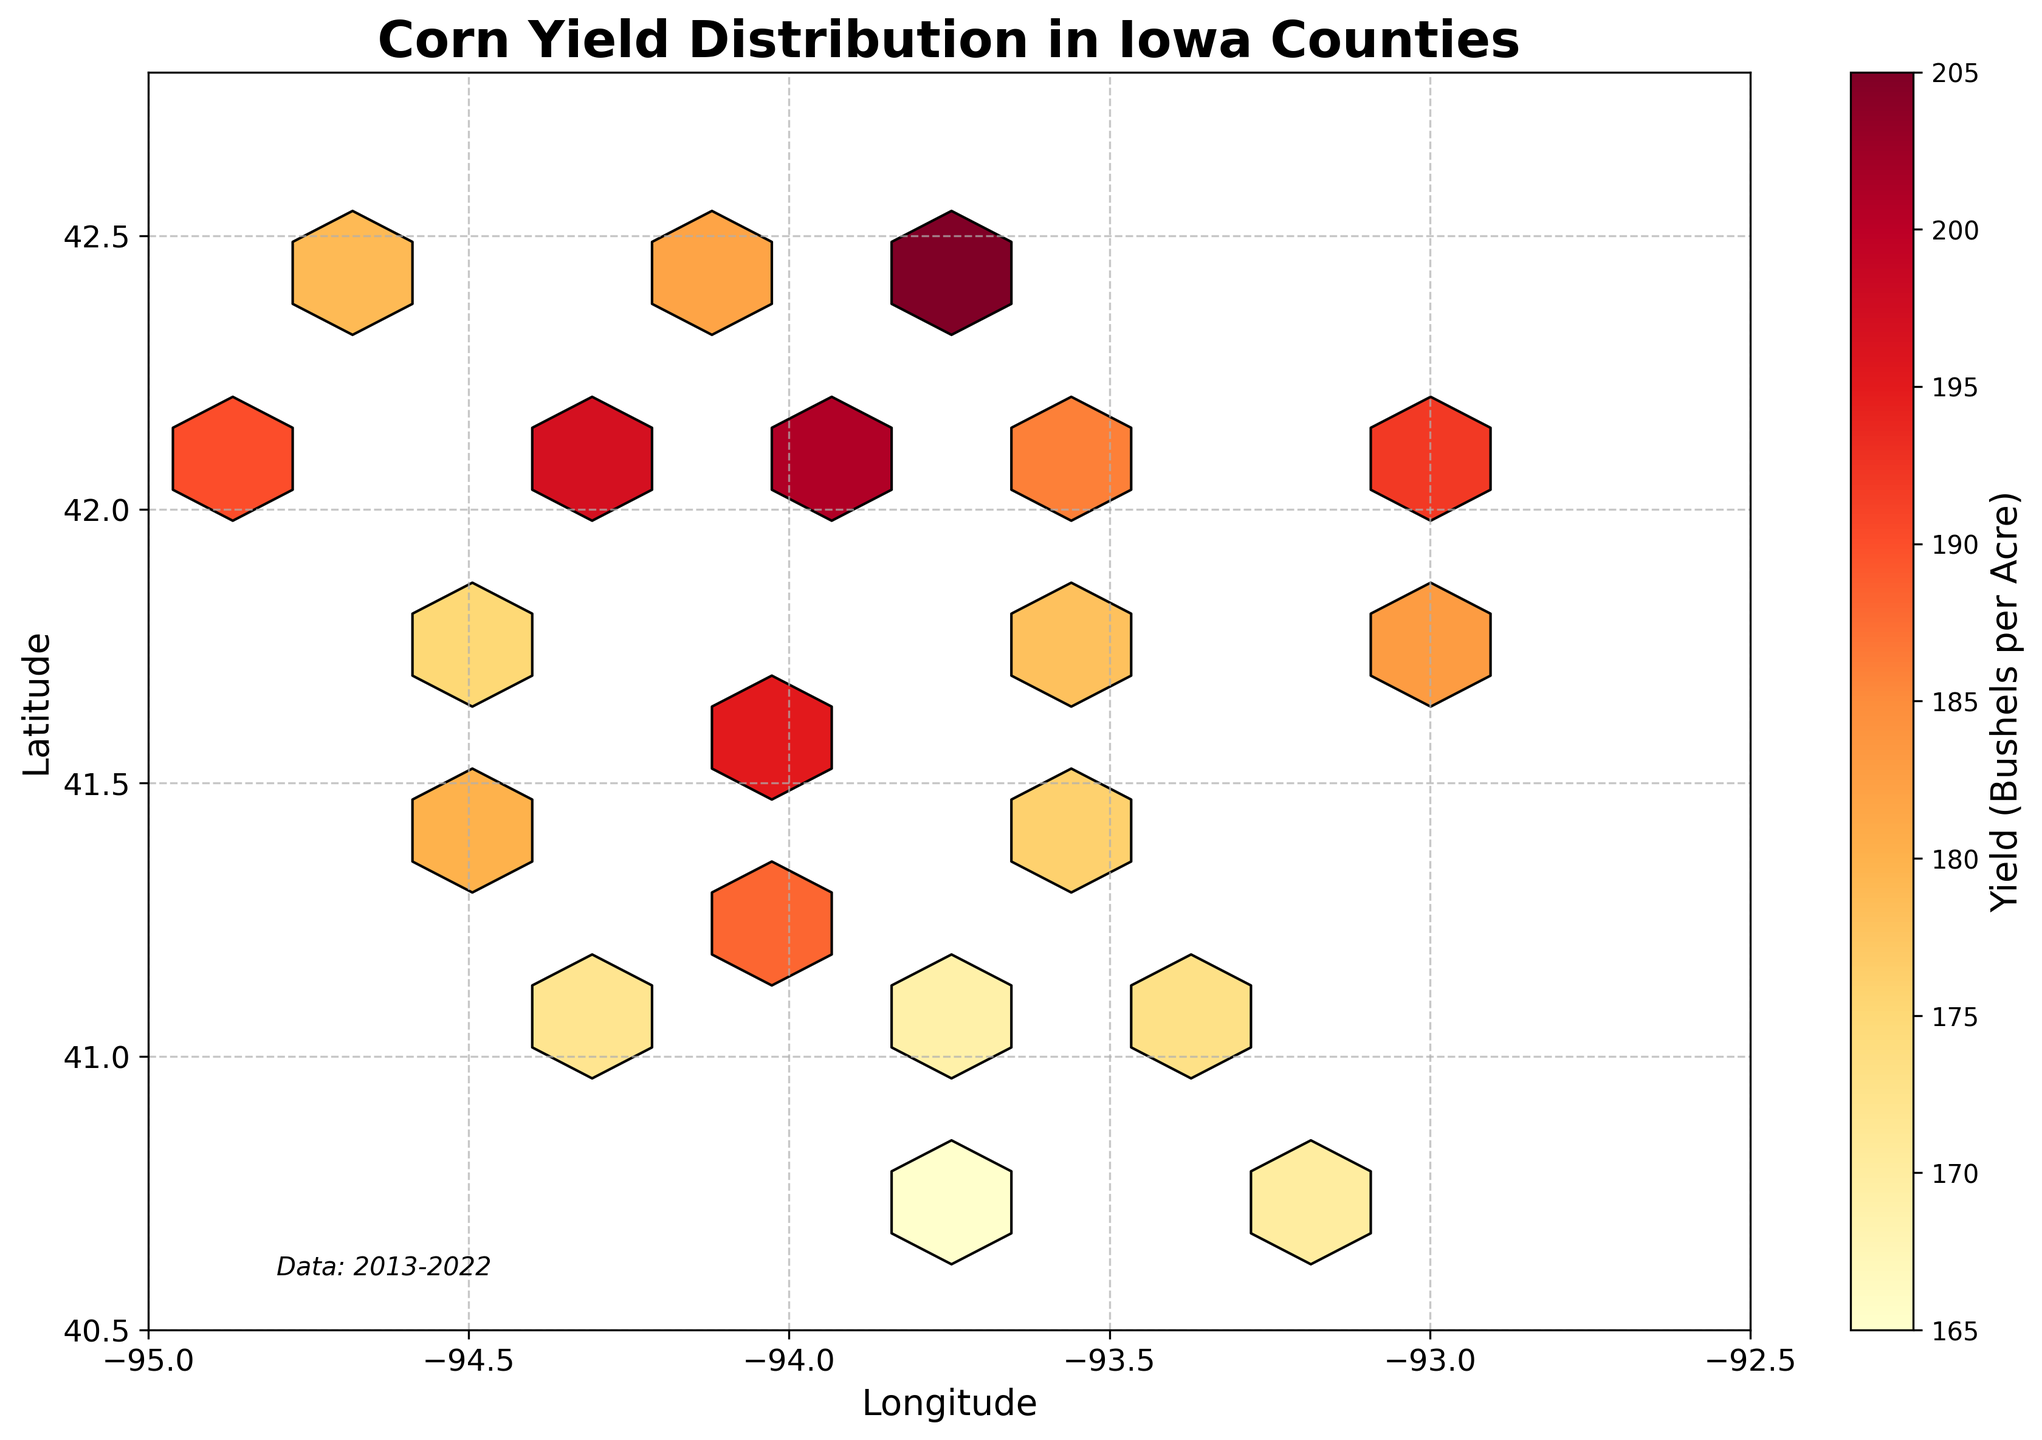What is the title of the hexbin plot? The title is usually written at the top of the figure; in this case, it reads "Corn Yield Distribution in Iowa Counties".
Answer: Corn Yield Distribution in Iowa Counties What is the color scheme used in the hexbin plot? The color scheme can be observed by looking at the gradient shown in the color bar. It ranges from yellow to red.
Answer: Yellow to red What does the color bar represent in the plot? The color bar typically denotes the values encoded by the color in the hexagon bins. Here, it labels "Yield (Bushels per Acre)", indicating the corn yield.
Answer: Yield (Bushels per Acre) What is the geographical range covered by the plot in terms of longitude? The x-axis labels the longitude range. The limits are from -95 to -92.5.
Answer: -95 to -92.5 Which area appears to have the highest corn yield based on the color intensity? The highest corn yield is represented by the darkest red color. This can be seen in the central region around the middle sections of the plot, indicating higher yields in those areas.
Answer: Central region What can you infer about the corn yield in Western vs. Eastern Iowa based on the plot? By comparing the colors on the western and eastern sides of the plot, one can note that the western part (left side) generally has lighter colors compared to the eastern part, indicating lower yields in the west compared to the east.
Answer: Lower in the west, higher in the east How does the plot indicate the data's timeframe? The timeframe of the data is mentioned as a text annotation at the bottom left corner of the plot, which reads "Data: 2013-2022".
Answer: 2013-2022 Are the hexagons in the plot packed closer together or spread out evenly? The hexagons are distributed based on the data spread. In this case, they are relatively evenly spread out, reflecting a broad distribution of corn yield data points across Iowa counties.
Answer: Spread out evenly What is the significance of the grid in the hexbin plot? The grid lines, shown in grey and dashed, provide a reference framework to help locate specific coordinates and understand spatial relationships within the plot.
Answer: Reference framework Which county's data would likely be found around the coordinates (-93.7, 42.0)? By cross-referencing the data table, these coordinates are around where Story, Boone, and Hamilton counties would be, which are in close geographical proximity and near these coordinates.
Answer: Story, Boone, Hamilton 